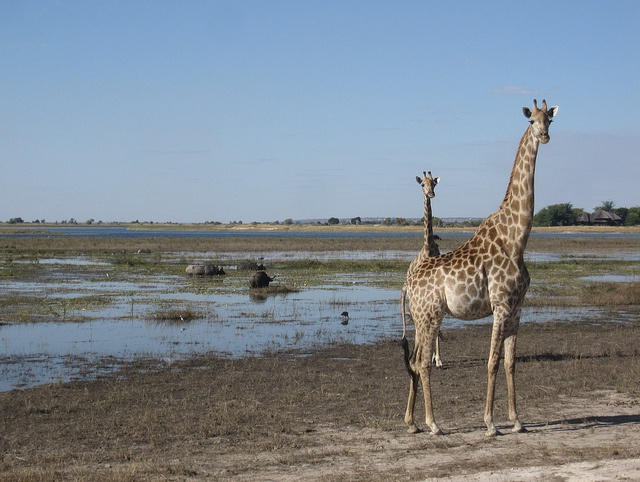Describe the objects in this image and their specific colors. I can see giraffe in darkgray, tan, and gray tones, giraffe in darkgray, black, and gray tones, cow in darkgray, black, and gray tones, cow in darkgray, black, and gray tones, and cow in darkgray, black, and gray tones in this image. 